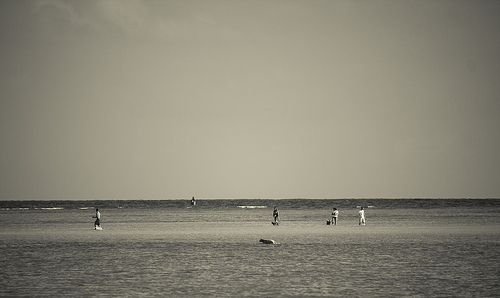a person in standing. In the endless scope of the beach, a person standing embodies a moment of stillness, perhaps punctuated by a contemplative gaze towards the waves or hands in pockets. 